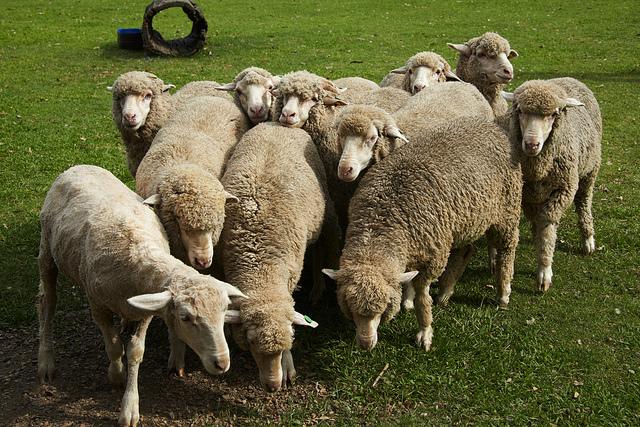What are the animals eating?
Short answer required. Grass. Is there a bike in between the sheep?
Short answer required. No. Are they fighting over food?
Keep it brief. No. Are these animals horses?
Keep it brief. No. How many animals are in the pic?
Short answer required. 11. The animals tagged?
Write a very short answer. No. 